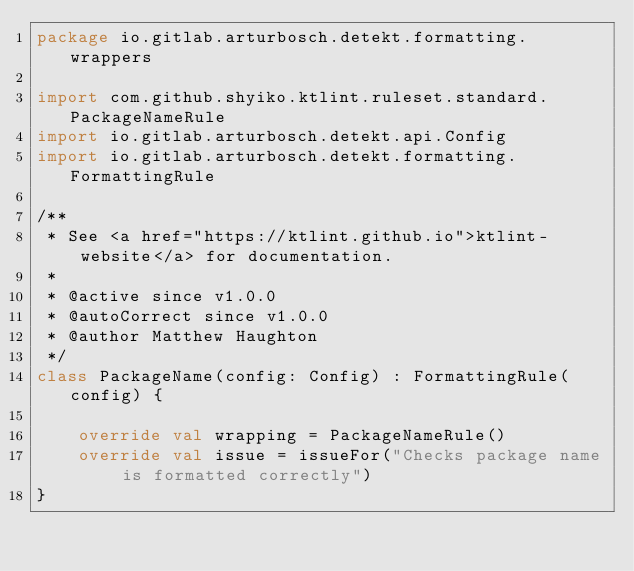Convert code to text. <code><loc_0><loc_0><loc_500><loc_500><_Kotlin_>package io.gitlab.arturbosch.detekt.formatting.wrappers

import com.github.shyiko.ktlint.ruleset.standard.PackageNameRule
import io.gitlab.arturbosch.detekt.api.Config
import io.gitlab.arturbosch.detekt.formatting.FormattingRule

/**
 * See <a href="https://ktlint.github.io">ktlint-website</a> for documentation.
 *
 * @active since v1.0.0
 * @autoCorrect since v1.0.0
 * @author Matthew Haughton
 */
class PackageName(config: Config) : FormattingRule(config) {

	override val wrapping = PackageNameRule()
	override val issue = issueFor("Checks package name is formatted correctly")
}
</code> 